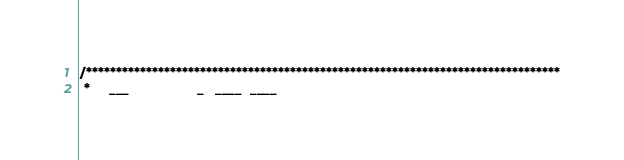Convert code to text. <code><loc_0><loc_0><loc_500><loc_500><_Java_>/*******************************************************************************
 *     ___                  _   ____  ____</code> 